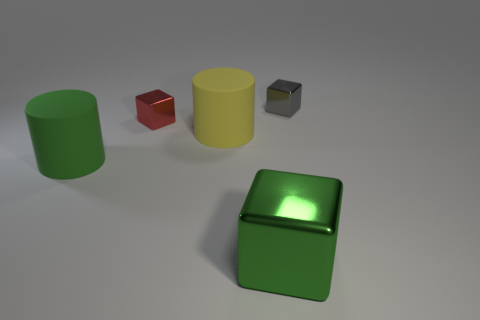Add 4 brown metal cubes. How many objects exist? 9 Subtract all blocks. How many objects are left? 2 Add 4 big yellow matte things. How many big yellow matte things are left? 5 Add 2 metal things. How many metal things exist? 5 Subtract 0 purple spheres. How many objects are left? 5 Subtract all metal things. Subtract all big shiny blocks. How many objects are left? 1 